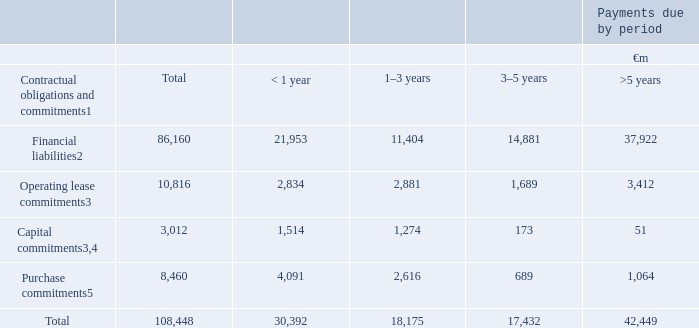Contractual obligations and commitments
A summary of our principal contractual financial obligations and commitments at 31 March 2019 are set out below. In addition, information in relation to our participation in the current German spectrum licence auction and our commitments arising from the Group’s announcement on 9 May 2018 that it had agreed to acquire Liberty Global’s operations in Germany, the Czech Republic, Hungary and Romania (are set out in note 28 “Commitments”).
Notes: 1 This table includes obligations to pay dividends to non-controlling shareholders (see “Dividends from associates and to non-controlling shareholders” on page 160). The table excludes current and deferred tax liabilities and obligations under post employment benefit schemes, details of which are provided in notes 6 “Taxation” and 25 “Post employment benefits” respectively. The table also excludes the contractual obligations of associates and joint ventures.
2 See note 21 “Capital and financial risk management”.
3 See note 28 “Commitments”.
4 Primarily related to spectrum and network infrastructure.
5 Primarily related to device purchase obligations.
What information does this table show? Summary of our principal contractual financial obligations and commitments at 31 march 2019. What are the total financial liabilities?
Answer scale should be: million. 86,160. What are the total operating lease commitments?
Answer scale should be: million. 10,816. How much financial liabilities are due for payment soonest?
Answer scale should be: million. < 1 year
Answer: 21,953. What percentage of total contractual obligations and commitments is the financial liabilities?
Answer scale should be: percent. 86,160/108,448
Answer: 79.45. What is the difference between percentage of total capital commitments and total purchase commitments against total contractual obligations and commitments respectively?
Answer scale should be: percent. (3,012/108,448) - (8,460/108,448)
Answer: -5.02. 